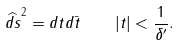<formula> <loc_0><loc_0><loc_500><loc_500>\widehat { d s } ^ { 2 } = d t d \bar { t } \quad | t | < \frac { 1 } { \delta ^ { \prime } } .</formula> 